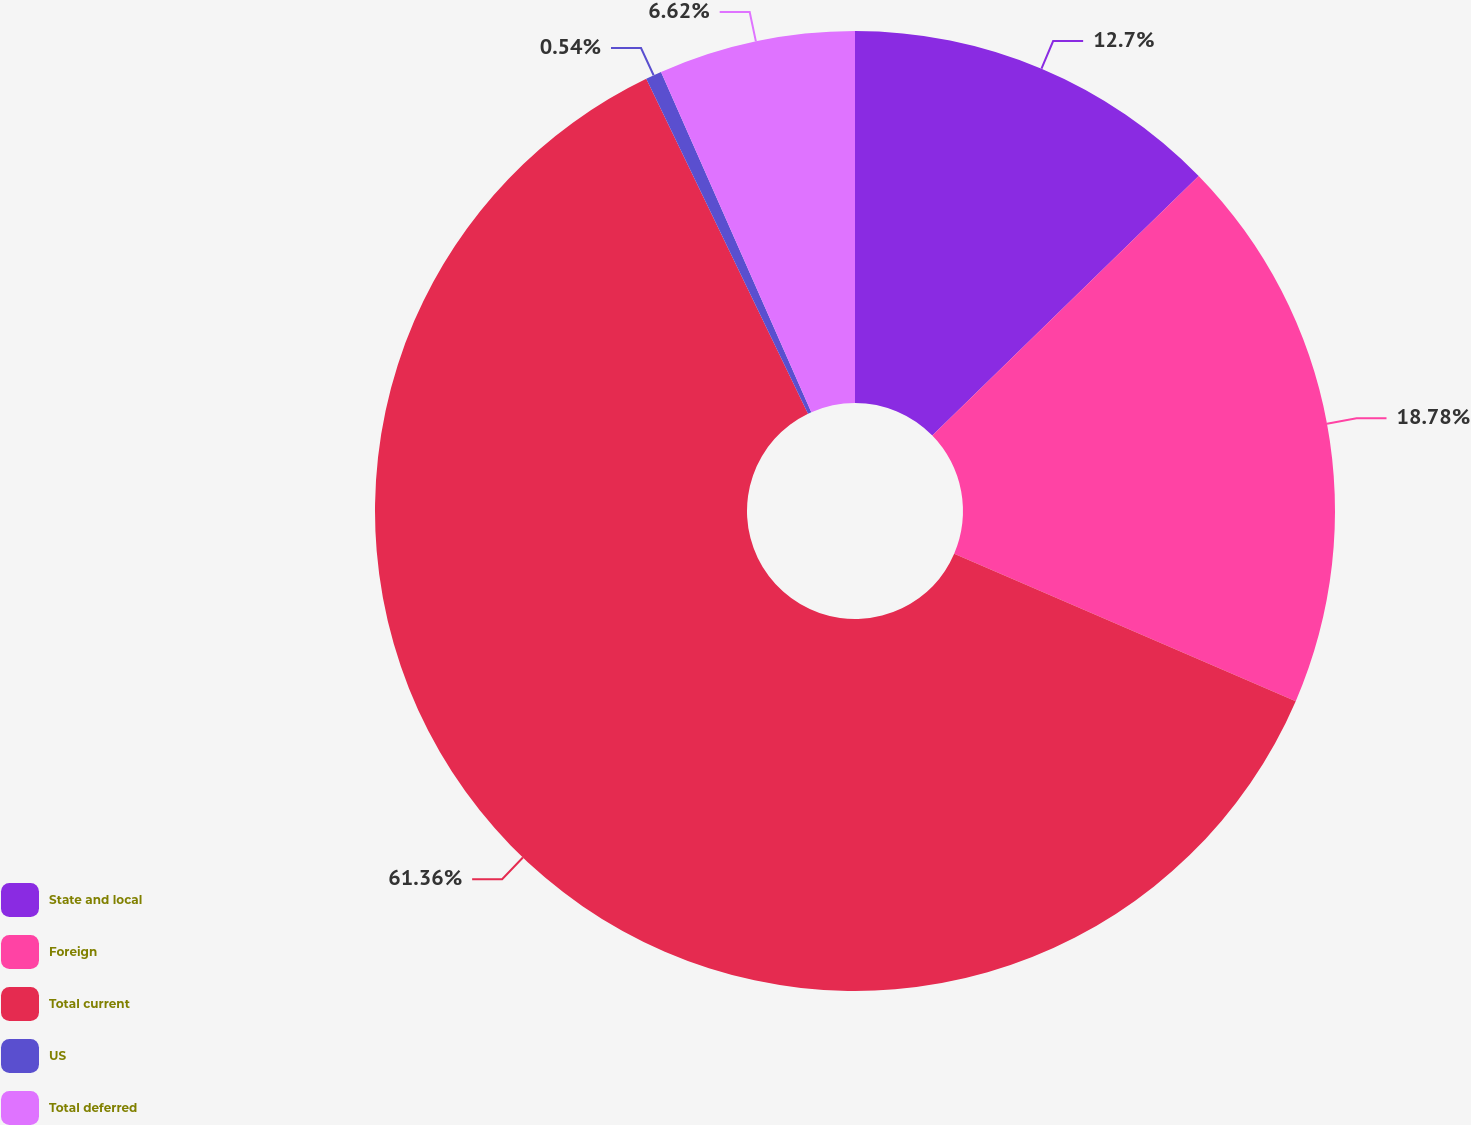Convert chart to OTSL. <chart><loc_0><loc_0><loc_500><loc_500><pie_chart><fcel>State and local<fcel>Foreign<fcel>Total current<fcel>US<fcel>Total deferred<nl><fcel>12.7%<fcel>18.78%<fcel>61.35%<fcel>0.54%<fcel>6.62%<nl></chart> 